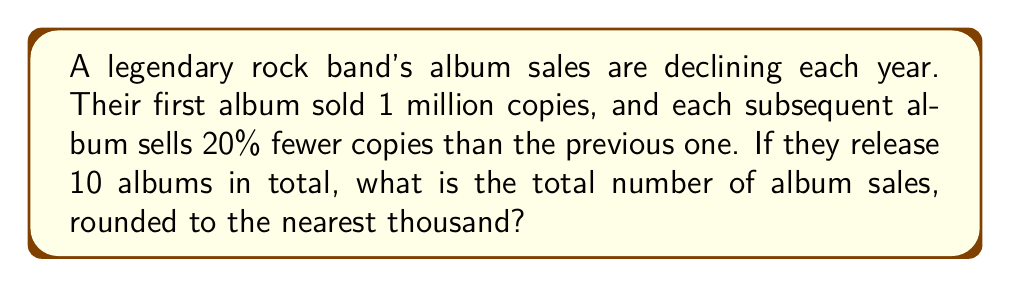What is the answer to this math problem? Let's approach this step-by-step:

1) This is a geometric sequence where each term is 80% of the previous term.
   The first term $a_1 = 1,000,000$ and the common ratio $r = 0.8$

2) We need to find the sum of this geometric series with 10 terms.
   The formula for the sum of a geometric series is:
   
   $$S_n = \frac{a_1(1-r^n)}{1-r}$$

   Where $a_1$ is the first term, $r$ is the common ratio, and $n$ is the number of terms.

3) Substituting our values:

   $$S_{10} = \frac{1,000,000(1-0.8^{10})}{1-0.8}$$

4) Let's calculate $0.8^{10}$:
   
   $$0.8^{10} \approx 0.1074$$

5) Now we can solve:

   $$S_{10} = \frac{1,000,000(1-0.1074)}{0.2}$$
   
   $$= \frac{1,000,000(0.8926)}{0.2}$$
   
   $$= 4,463,000$$

6) Rounding to the nearest thousand:

   $$4,463,000 \approx 4,463,000$$

Thus, the total album sales over 10 albums, rounded to the nearest thousand, is 4,463,000.
Answer: 4,463,000 